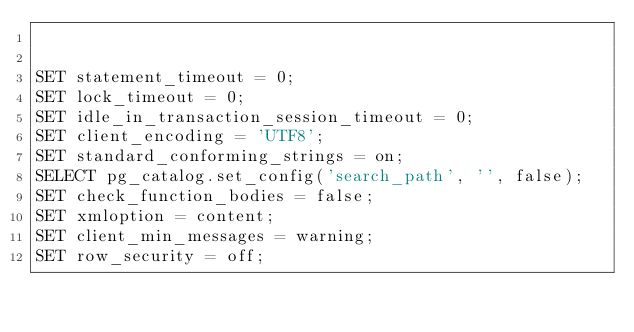<code> <loc_0><loc_0><loc_500><loc_500><_SQL_>

SET statement_timeout = 0;
SET lock_timeout = 0;
SET idle_in_transaction_session_timeout = 0;
SET client_encoding = 'UTF8';
SET standard_conforming_strings = on;
SELECT pg_catalog.set_config('search_path', '', false);
SET check_function_bodies = false;
SET xmloption = content;
SET client_min_messages = warning;
SET row_security = off;


</code> 